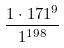Convert formula to latex. <formula><loc_0><loc_0><loc_500><loc_500>\frac { 1 \cdot 1 7 1 ^ { 9 } } { 1 ^ { 1 9 8 } }</formula> 